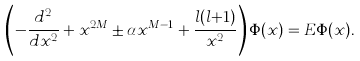Convert formula to latex. <formula><loc_0><loc_0><loc_500><loc_500>\left ( - \frac { d ^ { 2 } } { d x ^ { 2 } } + x ^ { 2 M } \pm \alpha x ^ { M - 1 } + \frac { l ( l { + } 1 ) } { x ^ { 2 } } \right ) \Phi ( x ) = E \Phi ( x ) .</formula> 